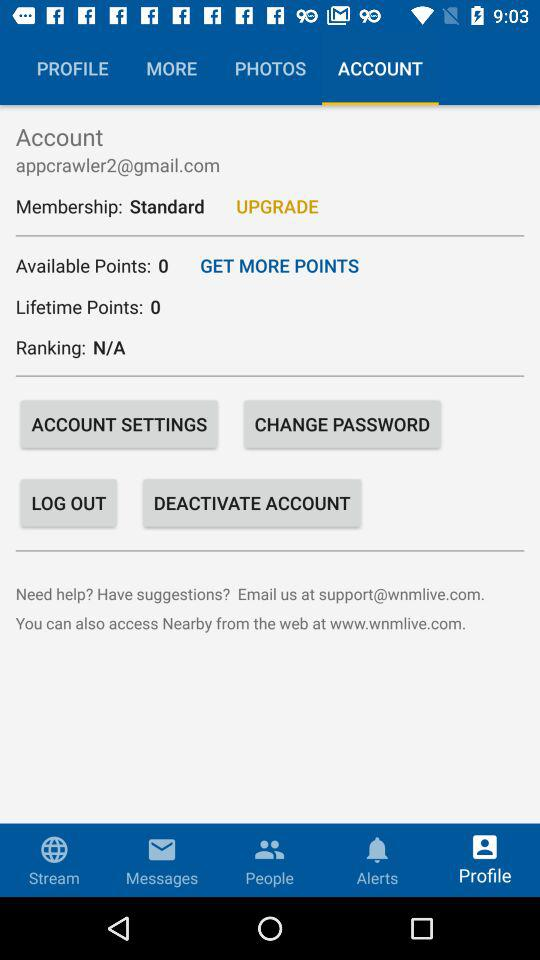How many points does the user have?
Answer the question using a single word or phrase. 0 